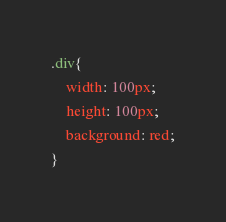<code> <loc_0><loc_0><loc_500><loc_500><_CSS_>.div{
    width: 100px;
    height: 100px;
    background: red;
}</code> 